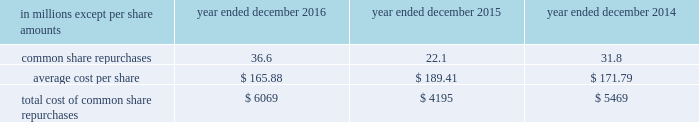The goldman sachs group , inc .
And subsidiaries notes to consolidated financial statements in connection with the firm 2019s prime brokerage and clearing businesses , the firm agrees to clear and settle on behalf of its clients the transactions entered into by them with other brokerage firms .
The firm 2019s obligations in respect of such transactions are secured by the assets in the client 2019s account as well as any proceeds received from the transactions cleared and settled by the firm on behalf of the client .
In connection with joint venture investments , the firm may issue loan guarantees under which it may be liable in the event of fraud , misappropriation , environmental liabilities and certain other matters involving the borrower .
The firm is unable to develop an estimate of the maximum payout under these guarantees and indemnifications .
However , management believes that it is unlikely the firm will have to make any material payments under these arrangements , and no material liabilities related to these guarantees and indemnifications have been recognized in the consolidated statements of financial condition as of december 2016 and december 2015 .
Other representations , warranties and indemnifications .
The firm provides representations and warranties to counterparties in connection with a variety of commercial transactions and occasionally indemnifies them against potential losses caused by the breach of those representations and warranties .
The firm may also provide indemnifications protecting against changes in or adverse application of certain u.s .
Tax laws in connection with ordinary-course transactions such as securities issuances , borrowings or derivatives .
In addition , the firm may provide indemnifications to some counterparties to protect them in the event additional taxes are owed or payments are withheld , due either to a change in or an adverse application of certain non-u.s .
Tax laws .
These indemnifications generally are standard contractual terms and are entered into in the ordinary course of business .
Generally , there are no stated or notional amounts included in these indemnifications , and the contingencies triggering the obligation to indemnify are not expected to occur .
The firm is unable to develop an estimate of the maximum payout under these guarantees and indemnifications .
However , management believes that it is unlikely the firm will have to make any material payments under these arrangements , and no material liabilities related to these arrangements have been recognized in the consolidated statements of financial condition as of december 2016 and december 2015 .
Guarantees of subsidiaries .
Group inc .
Fully and unconditionally guarantees the securities issued by gs finance corp. , a wholly-owned finance subsidiary of the group inc .
Has guaranteed the payment obligations of goldman , sachs & co .
( gs&co. ) and gs bank usa , subject to certain exceptions .
In addition , group inc .
Guarantees many of the obligations of its other consolidated subsidiaries on a transaction-by- transaction basis , as negotiated with counterparties .
Group inc .
Is unable to develop an estimate of the maximum payout under its subsidiary guarantees ; however , because these guaranteed obligations are also obligations of consolidated subsidiaries , group inc . 2019s liabilities as guarantor are not separately disclosed .
Note 19 .
Shareholders 2019 equity common equity dividends declared per common share were $ 2.60 in 2016 , $ 2.55 in 2015 and $ 2.25 in 2014 .
On january 17 , 2017 , group inc .
Declared a dividend of $ 0.65 per common share to be paid on march 30 , 2017 to common shareholders of record on march 2 , 2017 .
The firm 2019s share repurchase program is intended to help maintain the appropriate level of common equity .
The share repurchase program is effected primarily through regular open-market purchases ( which may include repurchase plans designed to comply with rule 10b5-1 ) , the amounts and timing of which are determined primarily by the firm 2019s current and projected capital position , but which may also be influenced by general market conditions and the prevailing price and trading volumes of the firm 2019s common stock .
Prior to repurchasing common stock , the firm must receive confirmation that the federal reserve board does not object to such capital actions .
The table below presents the amount of common stock repurchased by the firm under the share repurchase program. .
172 goldman sachs 2016 form 10-k .
In millions , for 2016 , 2015 , and 2014 what was the total amount of common share repurchases? 
Computations: table_sum(common share repurchases, none)
Answer: 90.5. 